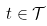Convert formula to latex. <formula><loc_0><loc_0><loc_500><loc_500>t \in { \mathcal { T } }</formula> 